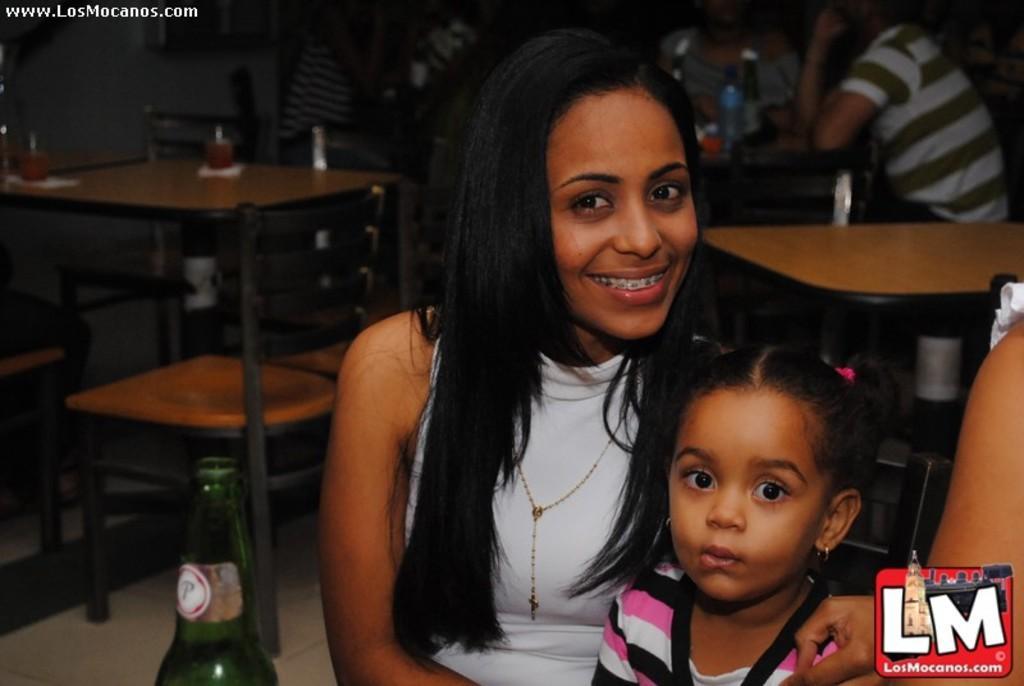Please provide a concise description of this image. This picture shows a woman and a girl sitting in the chairs. In front of them there is a bottle. The woman is smiling. In the background there are some tables and some chairs in which some people were sitting. 